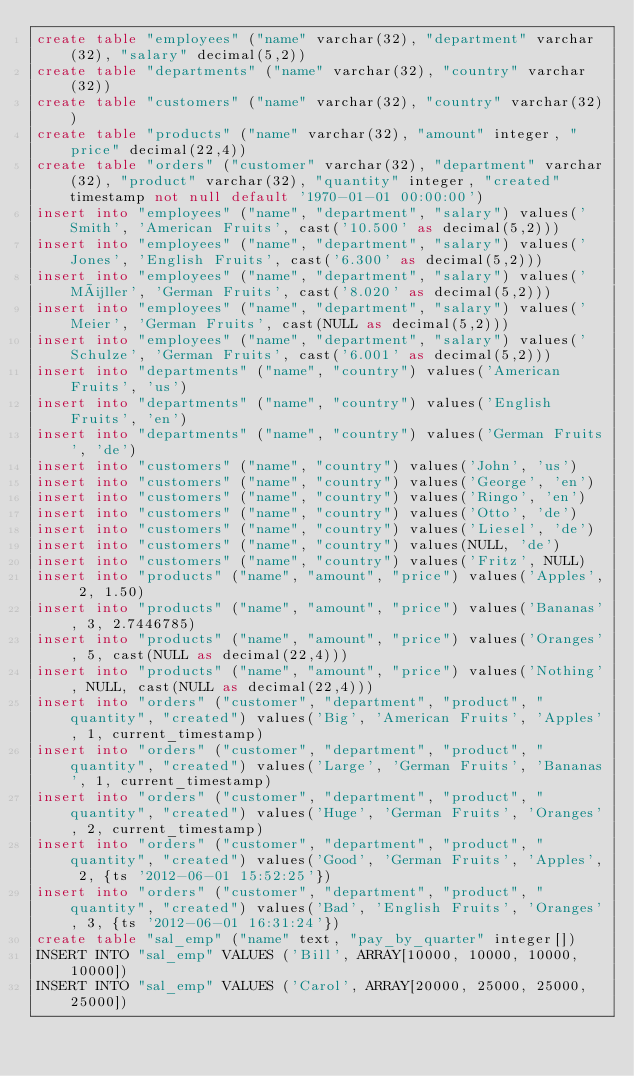Convert code to text. <code><loc_0><loc_0><loc_500><loc_500><_SQL_>create table "employees" ("name" varchar(32), "department" varchar(32), "salary" decimal(5,2))
create table "departments" ("name" varchar(32), "country" varchar(32))
create table "customers" ("name" varchar(32), "country" varchar(32))
create table "products" ("name" varchar(32), "amount" integer, "price" decimal(22,4))
create table "orders" ("customer" varchar(32), "department" varchar(32), "product" varchar(32), "quantity" integer, "created" timestamp not null default '1970-01-01 00:00:00')
insert into "employees" ("name", "department", "salary") values('Smith', 'American Fruits', cast('10.500' as decimal(5,2)))
insert into "employees" ("name", "department", "salary") values('Jones', 'English Fruits', cast('6.300' as decimal(5,2)))
insert into "employees" ("name", "department", "salary") values('Müller', 'German Fruits', cast('8.020' as decimal(5,2)))
insert into "employees" ("name", "department", "salary") values('Meier', 'German Fruits', cast(NULL as decimal(5,2)))
insert into "employees" ("name", "department", "salary") values('Schulze', 'German Fruits', cast('6.001' as decimal(5,2)))
insert into "departments" ("name", "country") values('American Fruits', 'us')
insert into "departments" ("name", "country") values('English Fruits', 'en')
insert into "departments" ("name", "country") values('German Fruits', 'de')
insert into "customers" ("name", "country") values('John', 'us')
insert into "customers" ("name", "country") values('George', 'en')
insert into "customers" ("name", "country") values('Ringo', 'en')
insert into "customers" ("name", "country") values('Otto', 'de')
insert into "customers" ("name", "country") values('Liesel', 'de')
insert into "customers" ("name", "country") values(NULL, 'de')
insert into "customers" ("name", "country") values('Fritz', NULL)
insert into "products" ("name", "amount", "price") values('Apples', 2, 1.50)
insert into "products" ("name", "amount", "price") values('Bananas', 3, 2.7446785)
insert into "products" ("name", "amount", "price") values('Oranges', 5, cast(NULL as decimal(22,4)))
insert into "products" ("name", "amount", "price") values('Nothing', NULL, cast(NULL as decimal(22,4)))
insert into "orders" ("customer", "department", "product", "quantity", "created") values('Big', 'American Fruits', 'Apples', 1, current_timestamp)
insert into "orders" ("customer", "department", "product", "quantity", "created") values('Large', 'German Fruits', 'Bananas', 1, current_timestamp)
insert into "orders" ("customer", "department", "product", "quantity", "created") values('Huge', 'German Fruits', 'Oranges', 2, current_timestamp)
insert into "orders" ("customer", "department", "product", "quantity", "created") values('Good', 'German Fruits', 'Apples', 2, {ts '2012-06-01 15:52:25'})
insert into "orders" ("customer", "department", "product", "quantity", "created") values('Bad', 'English Fruits', 'Oranges', 3, {ts '2012-06-01 16:31:24'})
create table "sal_emp" ("name" text, "pay_by_quarter" integer[])
INSERT INTO "sal_emp" VALUES ('Bill', ARRAY[10000, 10000, 10000, 10000])
INSERT INTO "sal_emp" VALUES ('Carol', ARRAY[20000, 25000, 25000, 25000])
</code> 